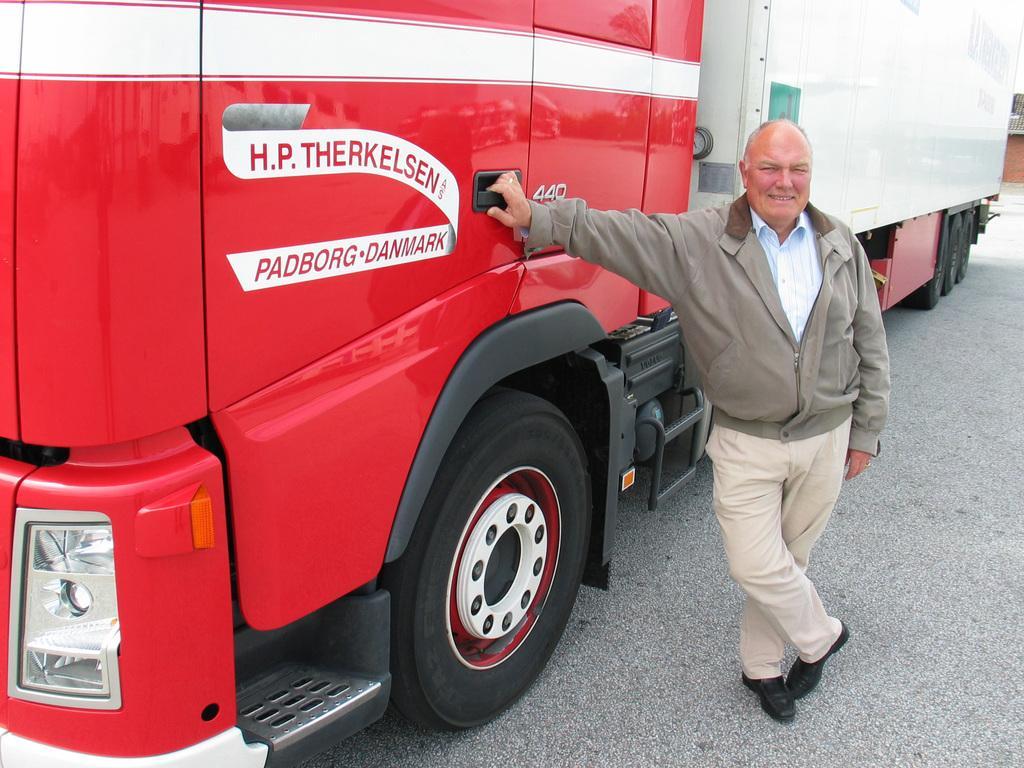How would you summarize this image in a sentence or two? In this image we can see a man standing. There is a vehicle. At the bottom there is a road. 